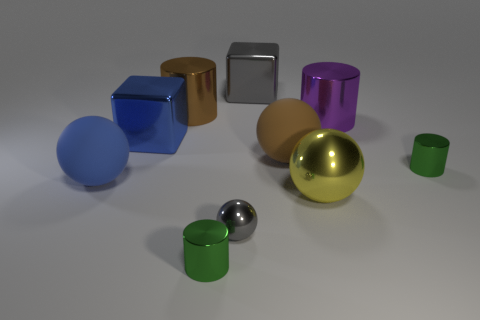Subtract 1 balls. How many balls are left? 3 Subtract all balls. How many objects are left? 6 Subtract all large brown things. Subtract all tiny cyan matte balls. How many objects are left? 8 Add 5 tiny green shiny cylinders. How many tiny green shiny cylinders are left? 7 Add 8 yellow objects. How many yellow objects exist? 9 Subtract 0 green balls. How many objects are left? 10 